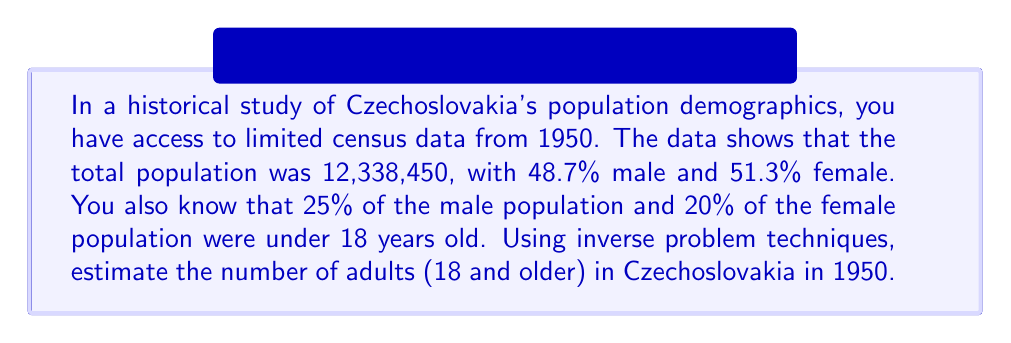Can you solve this math problem? Let's approach this step-by-step:

1) First, let's calculate the male and female populations:
   Male population: $12,338,450 \times 0.487 = 6,008,825$
   Female population: $12,338,450 \times 0.513 = 6,329,625$

2) Now, let's calculate the number of males and females under 18:
   Males under 18: $6,008,825 \times 0.25 = 1,502,206$
   Females under 18: $6,329,625 \times 0.20 = 1,265,925$

3) To find the total number of people under 18:
   $1,502,206 + 1,265,925 = 2,768,131$

4) The number of adults (18 and older) can be found by subtracting the number of people under 18 from the total population:

   $12,338,450 - 2,768,131 = 9,570,319$

This inverse problem technique allows us to reconstruct the adult population demographics using the limited census information provided.
Answer: 9,570,319 